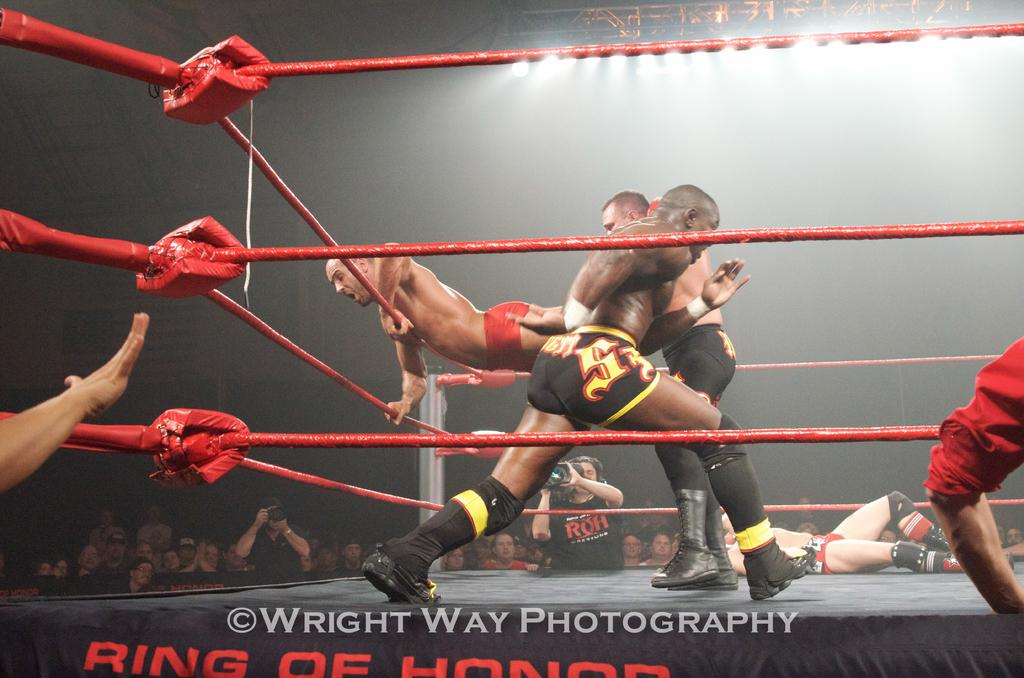<image>
Offer a succinct explanation of the picture presented. Wrestling Match debut that is taken by Write Way Photography, Ring of Honor. 